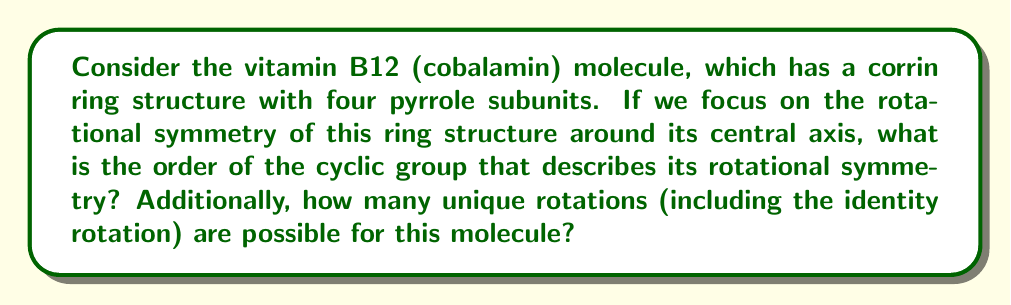Can you solve this math problem? To solve this problem, we need to apply group theory concepts to the rotational symmetry of the vitamin B12 molecule:

1. First, let's consider the structure of the corrin ring in vitamin B12:
   - The corrin ring consists of four pyrrole subunits arranged around a central cobalt atom.
   - These subunits are not perfectly symmetrical, but they do exhibit rotational symmetry.

2. Rotational symmetry in group theory:
   - Rotational symmetry is described by cyclic groups, denoted as $C_n$, where $n$ is the order of the group.
   - The order of the group represents the number of distinct rotations that bring the molecule back to a configuration indistinguishable from its initial state.

3. Analyzing the corrin ring structure:
   - The four pyrrole subunits are arranged at approximately 90° intervals around the central axis.
   - This means that a rotation of 90° (or $\frac{\pi}{2}$ radians) will bring the molecule to a configuration that looks the same as the initial state.

4. Determining the cyclic group:
   - Since a 90° rotation produces an indistinguishable configuration, and there are four such rotations possible before returning to the initial state, the cyclic group describing this symmetry is $C_4$.

5. Calculating the number of unique rotations:
   - In a cyclic group $C_n$, there are $n$ unique rotations, including the identity rotation (0° or 360°).
   - For $C_4$, the unique rotations are:
     $$\{0°, 90°, 180°, 270°\}$$ or $$\{0, \frac{\pi}{2}, \pi, \frac{3\pi}{2}\}$$ in radians

Therefore, the order of the cyclic group is 4, and there are 4 unique rotations possible for the vitamin B12 corrin ring structure.
Answer: The order of the cyclic group describing the rotational symmetry of the vitamin B12 corrin ring is 4 ($C_4$), and there are 4 unique rotations possible, including the identity rotation. 